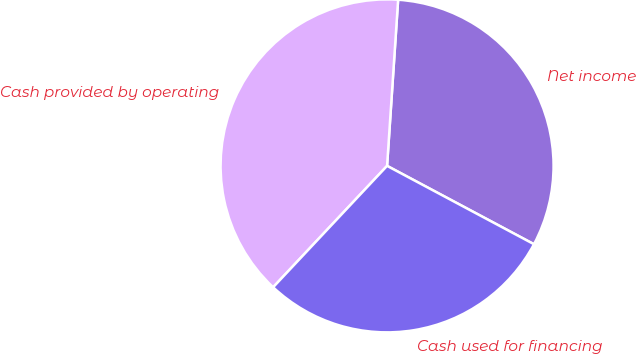Convert chart to OTSL. <chart><loc_0><loc_0><loc_500><loc_500><pie_chart><fcel>Net income<fcel>Cash provided by operating<fcel>Cash used for financing<nl><fcel>31.74%<fcel>39.06%<fcel>29.2%<nl></chart> 